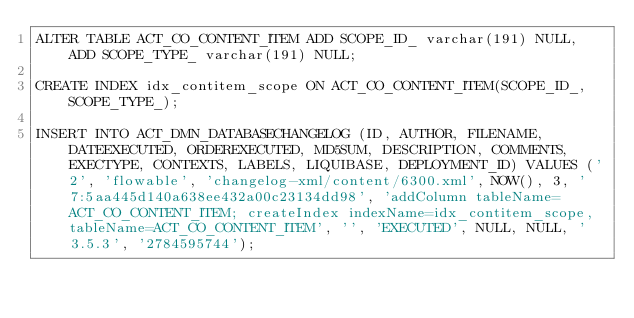<code> <loc_0><loc_0><loc_500><loc_500><_SQL_>ALTER TABLE ACT_CO_CONTENT_ITEM ADD SCOPE_ID_ varchar(191) NULL, ADD SCOPE_TYPE_ varchar(191) NULL;

CREATE INDEX idx_contitem_scope ON ACT_CO_CONTENT_ITEM(SCOPE_ID_, SCOPE_TYPE_);

INSERT INTO ACT_DMN_DATABASECHANGELOG (ID, AUTHOR, FILENAME, DATEEXECUTED, ORDEREXECUTED, MD5SUM, DESCRIPTION, COMMENTS, EXECTYPE, CONTEXTS, LABELS, LIQUIBASE, DEPLOYMENT_ID) VALUES ('2', 'flowable', 'changelog-xml/content/6300.xml', NOW(), 3, '7:5aa445d140a638ee432a00c23134dd98', 'addColumn tableName=ACT_CO_CONTENT_ITEM; createIndex indexName=idx_contitem_scope, tableName=ACT_CO_CONTENT_ITEM', '', 'EXECUTED', NULL, NULL, '3.5.3', '2784595744');

</code> 